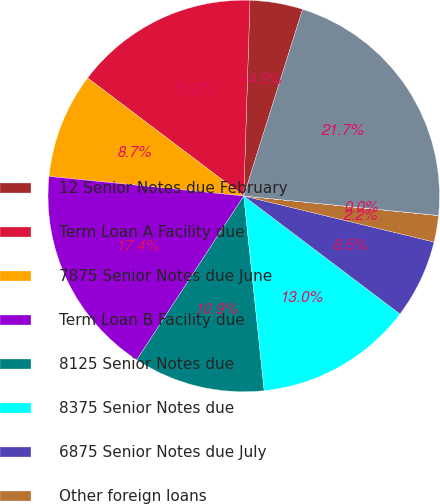Convert chart to OTSL. <chart><loc_0><loc_0><loc_500><loc_500><pie_chart><fcel>12 Senior Notes due February<fcel>Term Loan A Facility due<fcel>7875 Senior Notes due June<fcel>Term Loan B Facility due<fcel>8125 Senior Notes due<fcel>8375 Senior Notes due<fcel>6875 Senior Notes due July<fcel>Other foreign loans<fcel>Other domestic loans<fcel>Total debt<nl><fcel>4.35%<fcel>15.21%<fcel>8.7%<fcel>17.39%<fcel>10.87%<fcel>13.04%<fcel>6.52%<fcel>2.18%<fcel>0.01%<fcel>21.73%<nl></chart> 